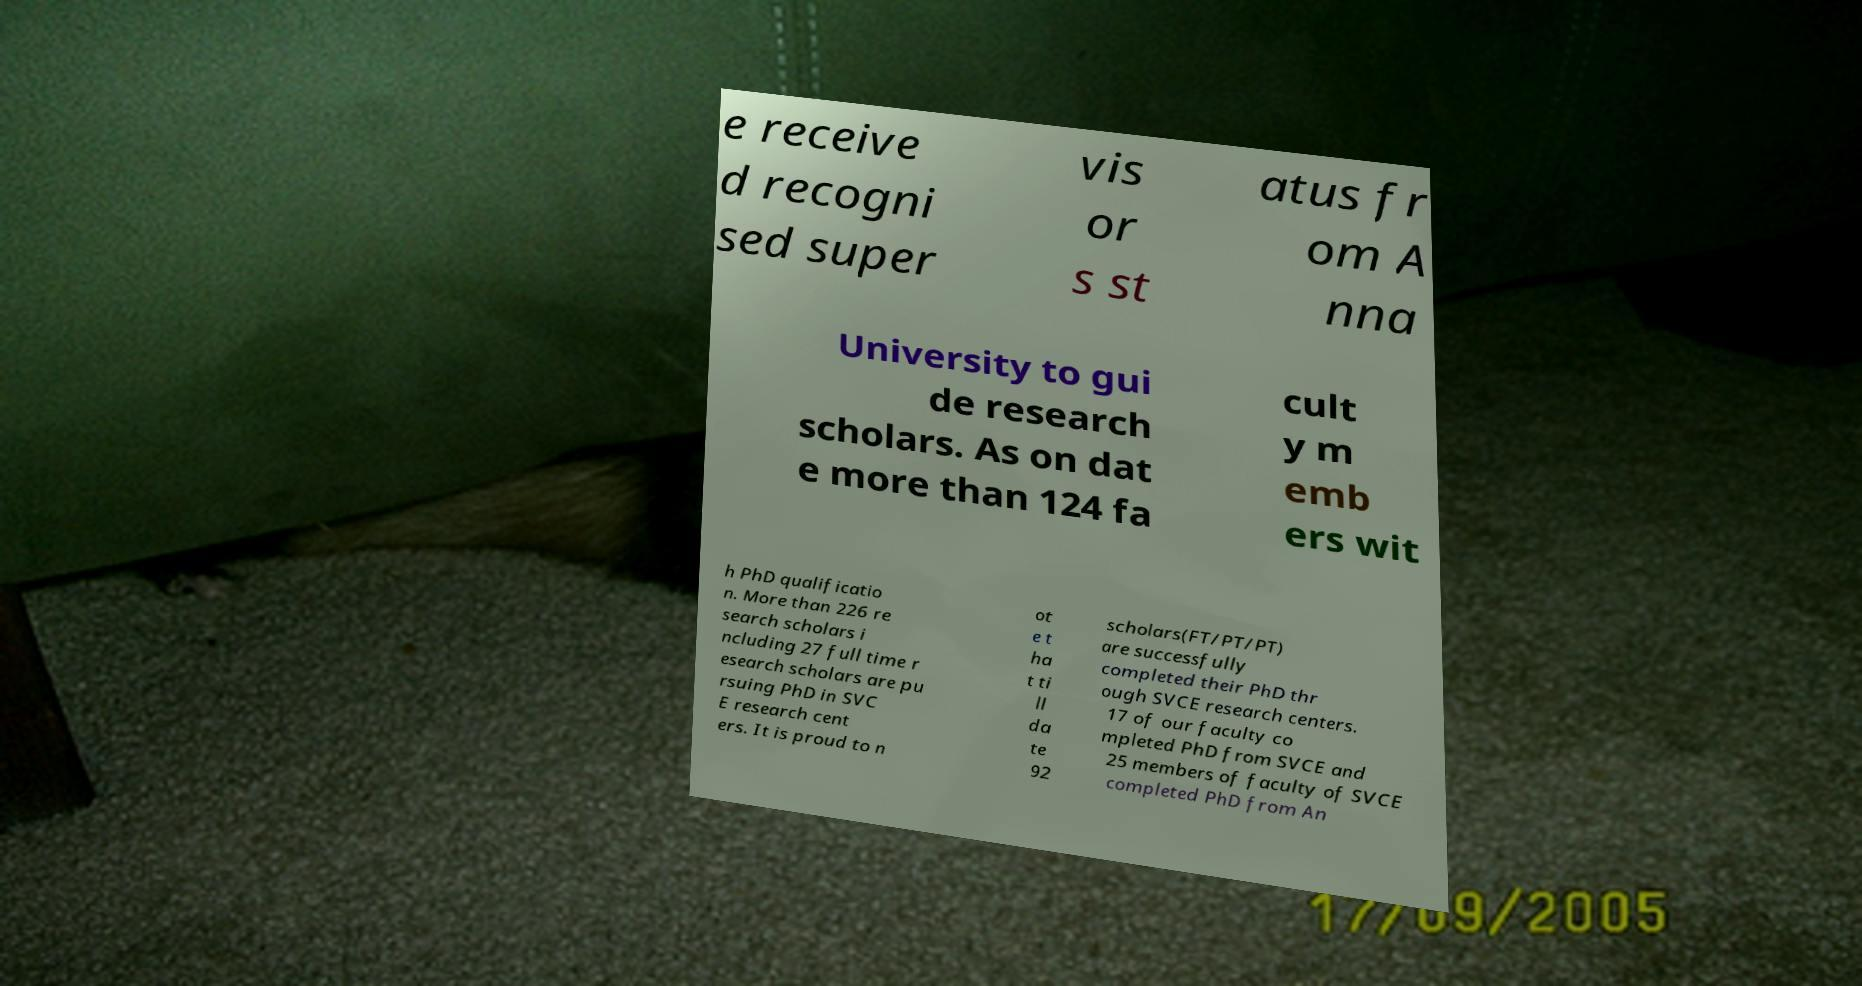Please read and relay the text visible in this image. What does it say? e receive d recogni sed super vis or s st atus fr om A nna University to gui de research scholars. As on dat e more than 124 fa cult y m emb ers wit h PhD qualificatio n. More than 226 re search scholars i ncluding 27 full time r esearch scholars are pu rsuing PhD in SVC E research cent ers. It is proud to n ot e t ha t ti ll da te 92 scholars(FT/PT/PT) are successfully completed their PhD thr ough SVCE research centers. 17 of our faculty co mpleted PhD from SVCE and 25 members of faculty of SVCE completed PhD from An 